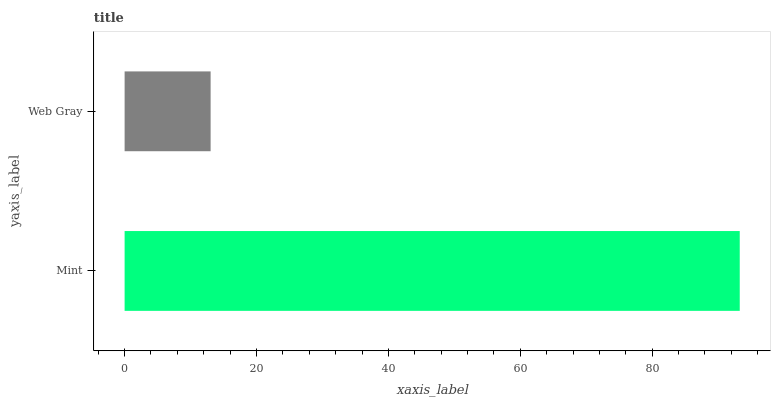Is Web Gray the minimum?
Answer yes or no. Yes. Is Mint the maximum?
Answer yes or no. Yes. Is Web Gray the maximum?
Answer yes or no. No. Is Mint greater than Web Gray?
Answer yes or no. Yes. Is Web Gray less than Mint?
Answer yes or no. Yes. Is Web Gray greater than Mint?
Answer yes or no. No. Is Mint less than Web Gray?
Answer yes or no. No. Is Mint the high median?
Answer yes or no. Yes. Is Web Gray the low median?
Answer yes or no. Yes. Is Web Gray the high median?
Answer yes or no. No. Is Mint the low median?
Answer yes or no. No. 